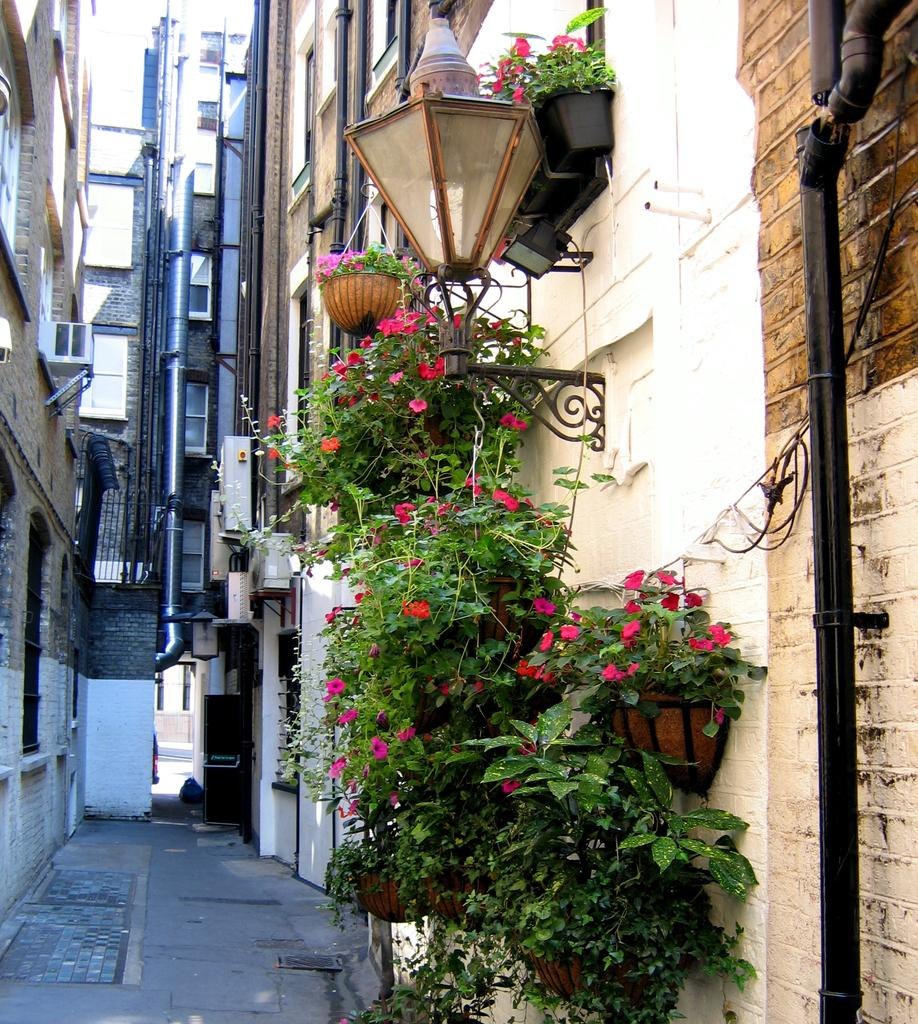What type of structures can be seen in the image? There are buildings in the image. Are there any objects near the buildings? Yes, there are flower pots near the buildings. Can you tell me what page the cave is located on in the image? There is no cave present in the image, so it cannot be located on any page. 